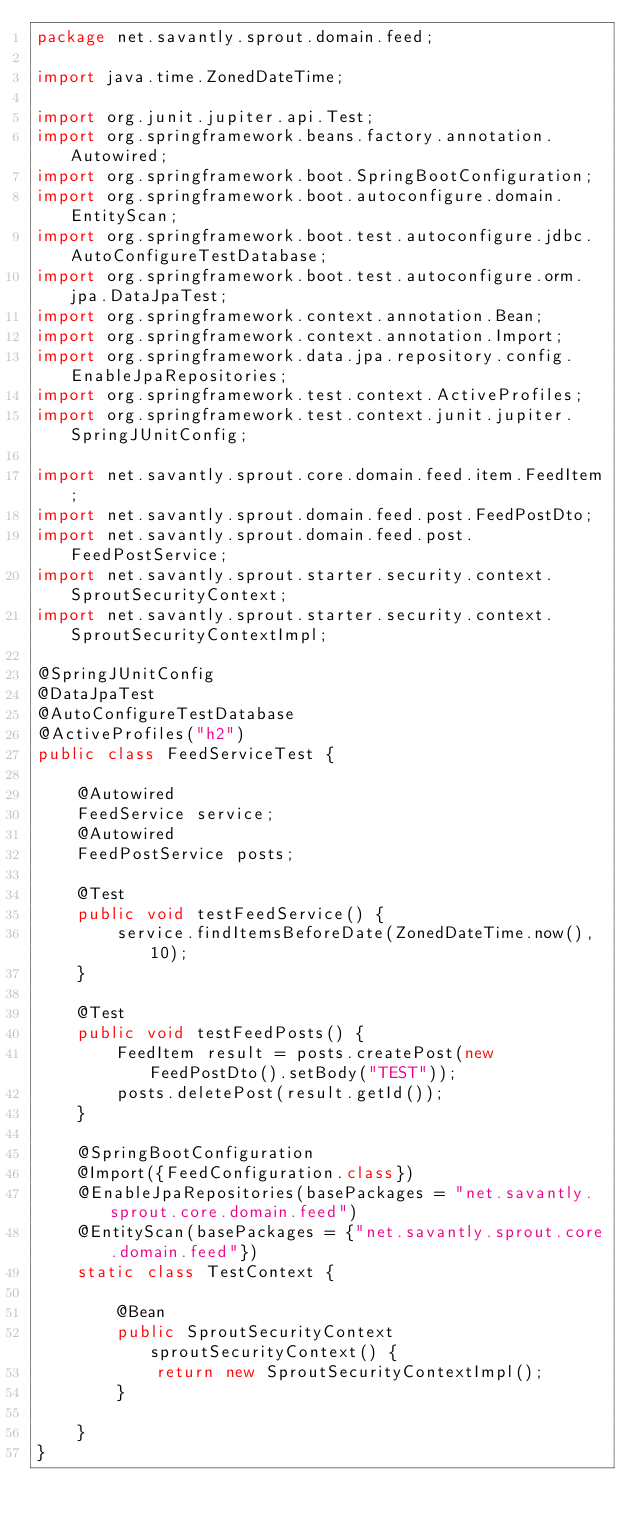Convert code to text. <code><loc_0><loc_0><loc_500><loc_500><_Java_>package net.savantly.sprout.domain.feed;

import java.time.ZonedDateTime;

import org.junit.jupiter.api.Test;
import org.springframework.beans.factory.annotation.Autowired;
import org.springframework.boot.SpringBootConfiguration;
import org.springframework.boot.autoconfigure.domain.EntityScan;
import org.springframework.boot.test.autoconfigure.jdbc.AutoConfigureTestDatabase;
import org.springframework.boot.test.autoconfigure.orm.jpa.DataJpaTest;
import org.springframework.context.annotation.Bean;
import org.springframework.context.annotation.Import;
import org.springframework.data.jpa.repository.config.EnableJpaRepositories;
import org.springframework.test.context.ActiveProfiles;
import org.springframework.test.context.junit.jupiter.SpringJUnitConfig;

import net.savantly.sprout.core.domain.feed.item.FeedItem;
import net.savantly.sprout.domain.feed.post.FeedPostDto;
import net.savantly.sprout.domain.feed.post.FeedPostService;
import net.savantly.sprout.starter.security.context.SproutSecurityContext;
import net.savantly.sprout.starter.security.context.SproutSecurityContextImpl;

@SpringJUnitConfig
@DataJpaTest
@AutoConfigureTestDatabase
@ActiveProfiles("h2")
public class FeedServiceTest {

	@Autowired
	FeedService service;
	@Autowired
	FeedPostService posts;

	@Test
	public void testFeedService() {
		service.findItemsBeforeDate(ZonedDateTime.now(), 10);
	}

	@Test
	public void testFeedPosts() {
		FeedItem result = posts.createPost(new FeedPostDto().setBody("TEST"));
		posts.deletePost(result.getId());
	}

	@SpringBootConfiguration
	@Import({FeedConfiguration.class})
	@EnableJpaRepositories(basePackages = "net.savantly.sprout.core.domain.feed")
	@EntityScan(basePackages = {"net.savantly.sprout.core.domain.feed"})
	static class TestContext {
		
		@Bean
		public SproutSecurityContext sproutSecurityContext() {
			return new SproutSecurityContextImpl();
		}

	}
}
</code> 